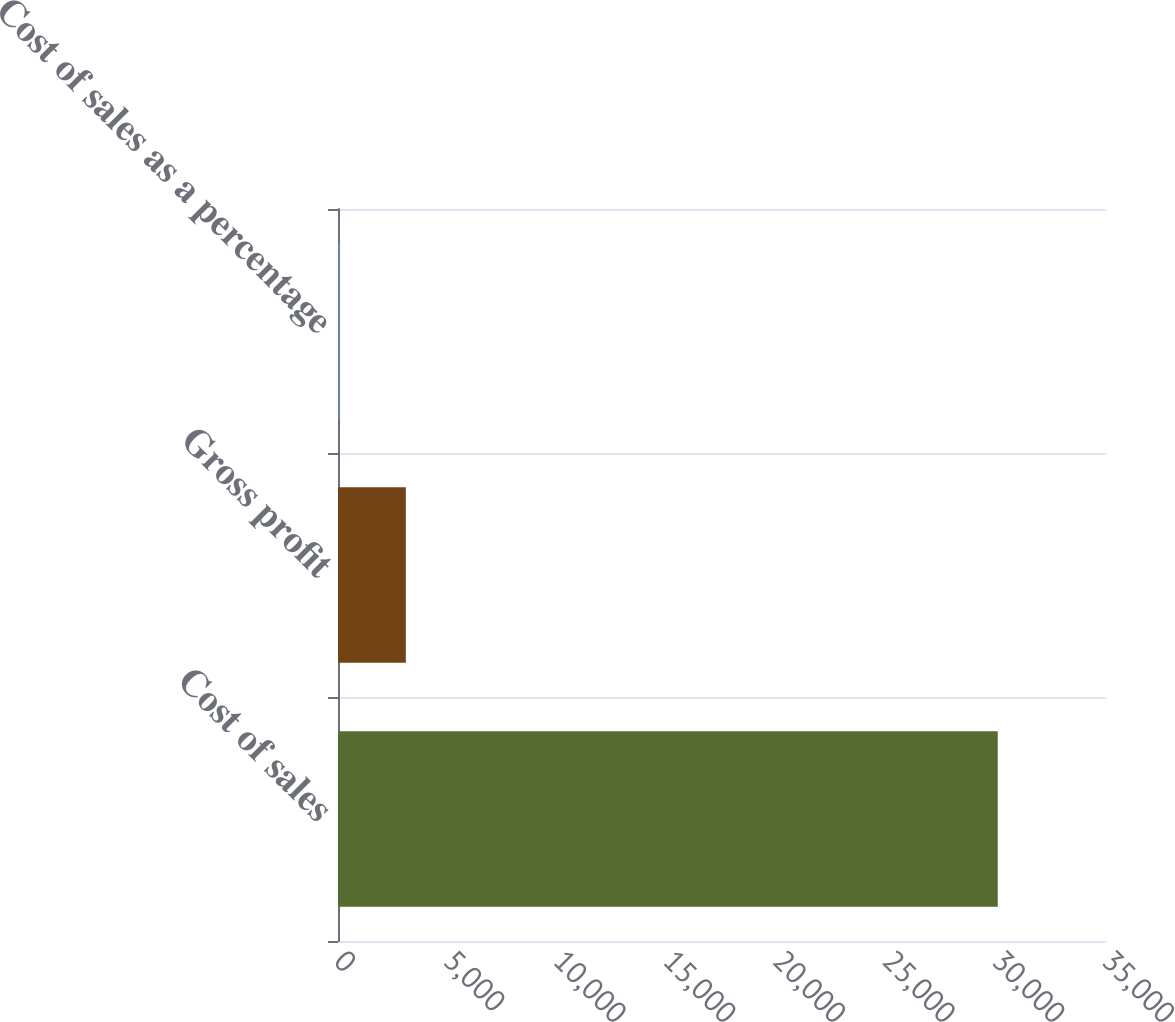Convert chart. <chart><loc_0><loc_0><loc_500><loc_500><bar_chart><fcel>Cost of sales<fcel>Gross profit<fcel>Cost of sales as a percentage<nl><fcel>30067<fcel>3090.58<fcel>93.2<nl></chart> 